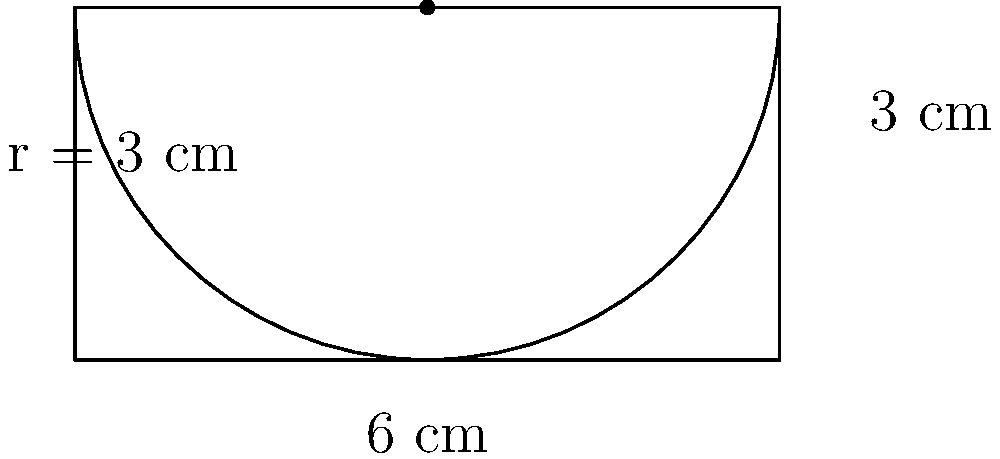Hey Bruno, remember our discussions about composite shapes? Here's a challenge for you: The figure shows a rectangle with a semi-circle on top. The rectangle has a width of 6 cm and a height of 3 cm. The radius of the semi-circle is equal to half the width of the rectangle. What is the total area of this composite shape? Round your answer to two decimal places. Let's break this down step-by-step, Bruno:

1) First, let's calculate the area of the rectangle:
   $A_{rectangle} = length \times width = 6 \text{ cm} \times 3 \text{ cm} = 18 \text{ cm}^2$

2) Now, for the semi-circle. Its radius is half the width of the rectangle:
   $r = 6 \text{ cm} \div 2 = 3 \text{ cm}$

3) The area of a full circle is $\pi r^2$, so the area of a semi-circle is half of that:
   $A_{semi-circle} = \frac{1}{2} \pi r^2 = \frac{1}{2} \pi (3 \text{ cm})^2 = \frac{9\pi}{2} \text{ cm}^2$

4) To get the total area, we add the areas of the rectangle and the semi-circle:
   $A_{total} = A_{rectangle} + A_{semi-circle} = 18 \text{ cm}^2 + \frac{9\pi}{2} \text{ cm}^2$

5) Let's calculate this:
   $A_{total} = 18 + \frac{9\pi}{2} \approx 18 + 14.14 = 32.14 \text{ cm}^2$

6) Rounding to two decimal places, we get 32.14 cm².
Answer: 32.14 cm² 